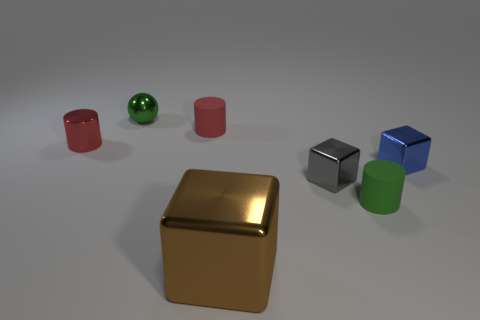Add 1 large green rubber cylinders. How many objects exist? 8 Subtract all balls. How many objects are left? 6 Subtract 1 brown cubes. How many objects are left? 6 Subtract all large brown metallic objects. Subtract all blocks. How many objects are left? 3 Add 1 tiny matte cylinders. How many tiny matte cylinders are left? 3 Add 2 tiny cyan metal cubes. How many tiny cyan metal cubes exist? 2 